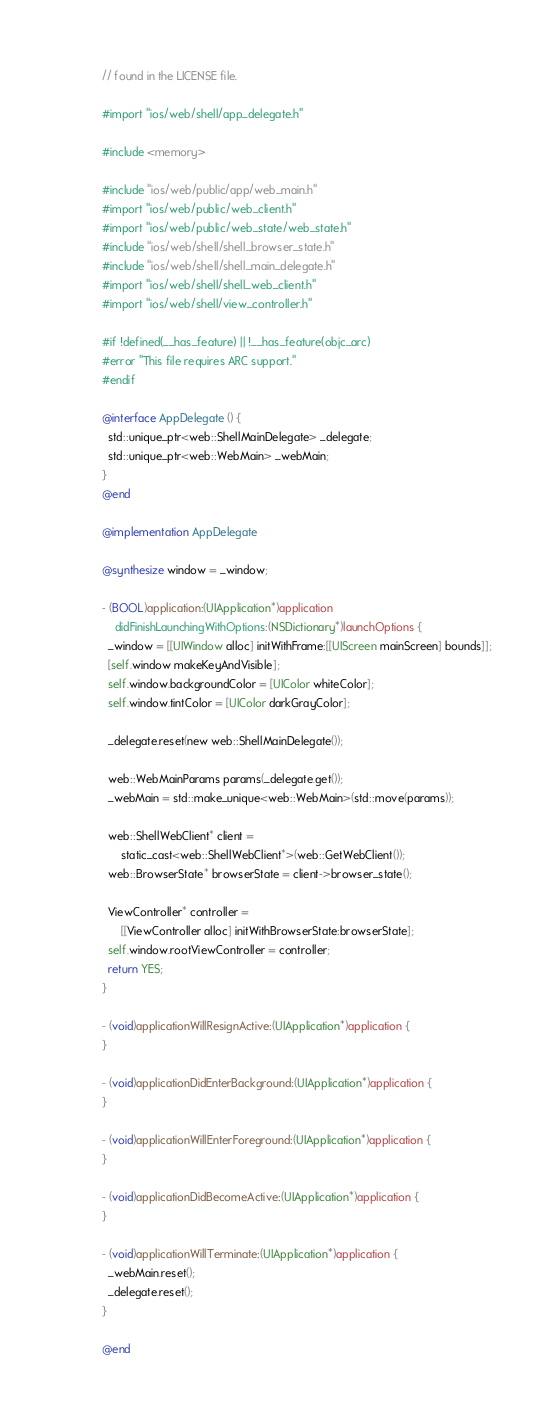Convert code to text. <code><loc_0><loc_0><loc_500><loc_500><_ObjectiveC_>// found in the LICENSE file.

#import "ios/web/shell/app_delegate.h"

#include <memory>

#include "ios/web/public/app/web_main.h"
#import "ios/web/public/web_client.h"
#import "ios/web/public/web_state/web_state.h"
#include "ios/web/shell/shell_browser_state.h"
#include "ios/web/shell/shell_main_delegate.h"
#import "ios/web/shell/shell_web_client.h"
#import "ios/web/shell/view_controller.h"

#if !defined(__has_feature) || !__has_feature(objc_arc)
#error "This file requires ARC support."
#endif

@interface AppDelegate () {
  std::unique_ptr<web::ShellMainDelegate> _delegate;
  std::unique_ptr<web::WebMain> _webMain;
}
@end

@implementation AppDelegate

@synthesize window = _window;

- (BOOL)application:(UIApplication*)application
    didFinishLaunchingWithOptions:(NSDictionary*)launchOptions {
  _window = [[UIWindow alloc] initWithFrame:[[UIScreen mainScreen] bounds]];
  [self.window makeKeyAndVisible];
  self.window.backgroundColor = [UIColor whiteColor];
  self.window.tintColor = [UIColor darkGrayColor];

  _delegate.reset(new web::ShellMainDelegate());

  web::WebMainParams params(_delegate.get());
  _webMain = std::make_unique<web::WebMain>(std::move(params));

  web::ShellWebClient* client =
      static_cast<web::ShellWebClient*>(web::GetWebClient());
  web::BrowserState* browserState = client->browser_state();

  ViewController* controller =
      [[ViewController alloc] initWithBrowserState:browserState];
  self.window.rootViewController = controller;
  return YES;
}

- (void)applicationWillResignActive:(UIApplication*)application {
}

- (void)applicationDidEnterBackground:(UIApplication*)application {
}

- (void)applicationWillEnterForeground:(UIApplication*)application {
}

- (void)applicationDidBecomeActive:(UIApplication*)application {
}

- (void)applicationWillTerminate:(UIApplication*)application {
  _webMain.reset();
  _delegate.reset();
}

@end
</code> 